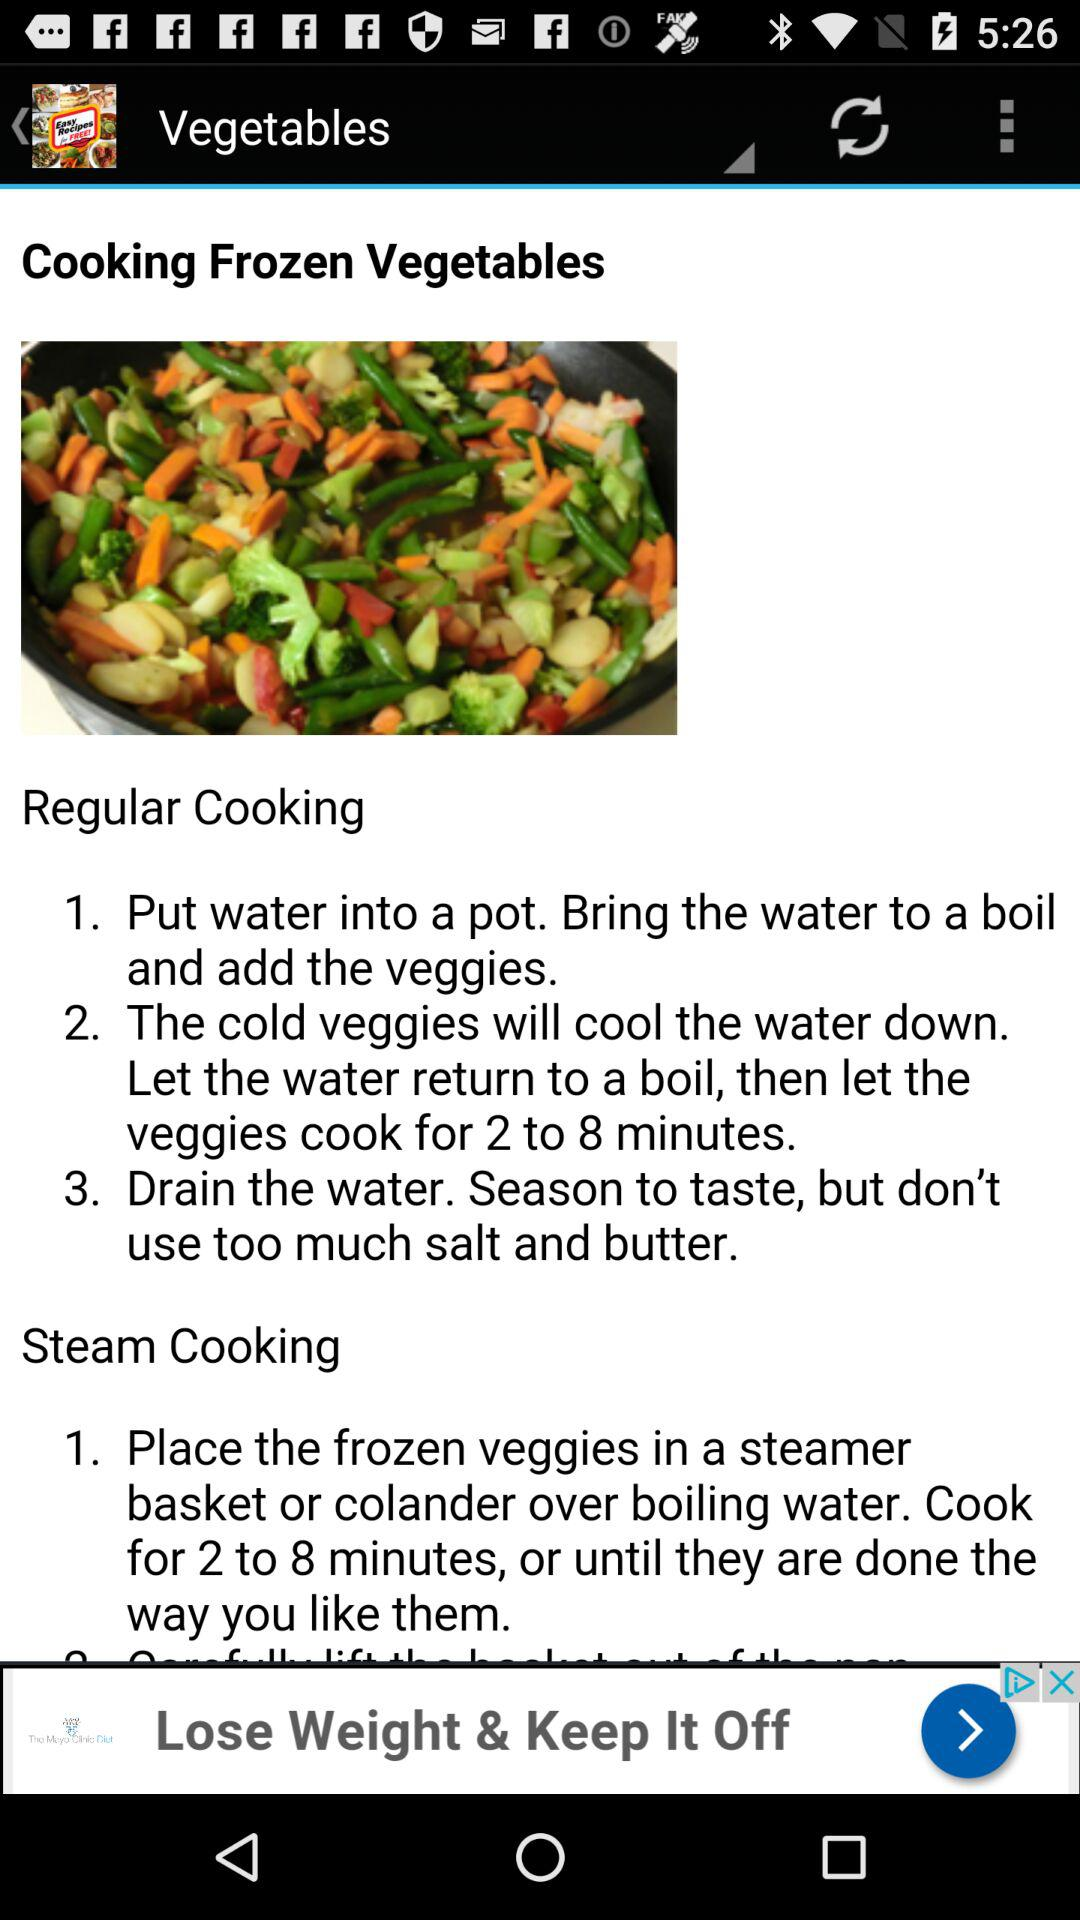How many steps are in the regular cooking method?
Answer the question using a single word or phrase. 3 